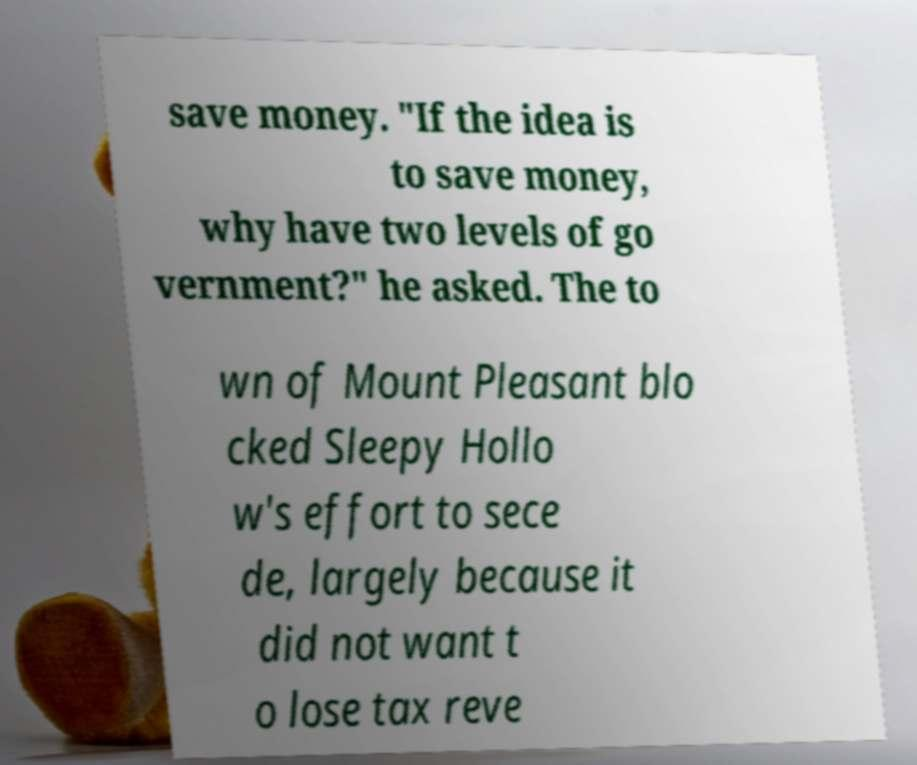For documentation purposes, I need the text within this image transcribed. Could you provide that? save money. "If the idea is to save money, why have two levels of go vernment?" he asked. The to wn of Mount Pleasant blo cked Sleepy Hollo w's effort to sece de, largely because it did not want t o lose tax reve 